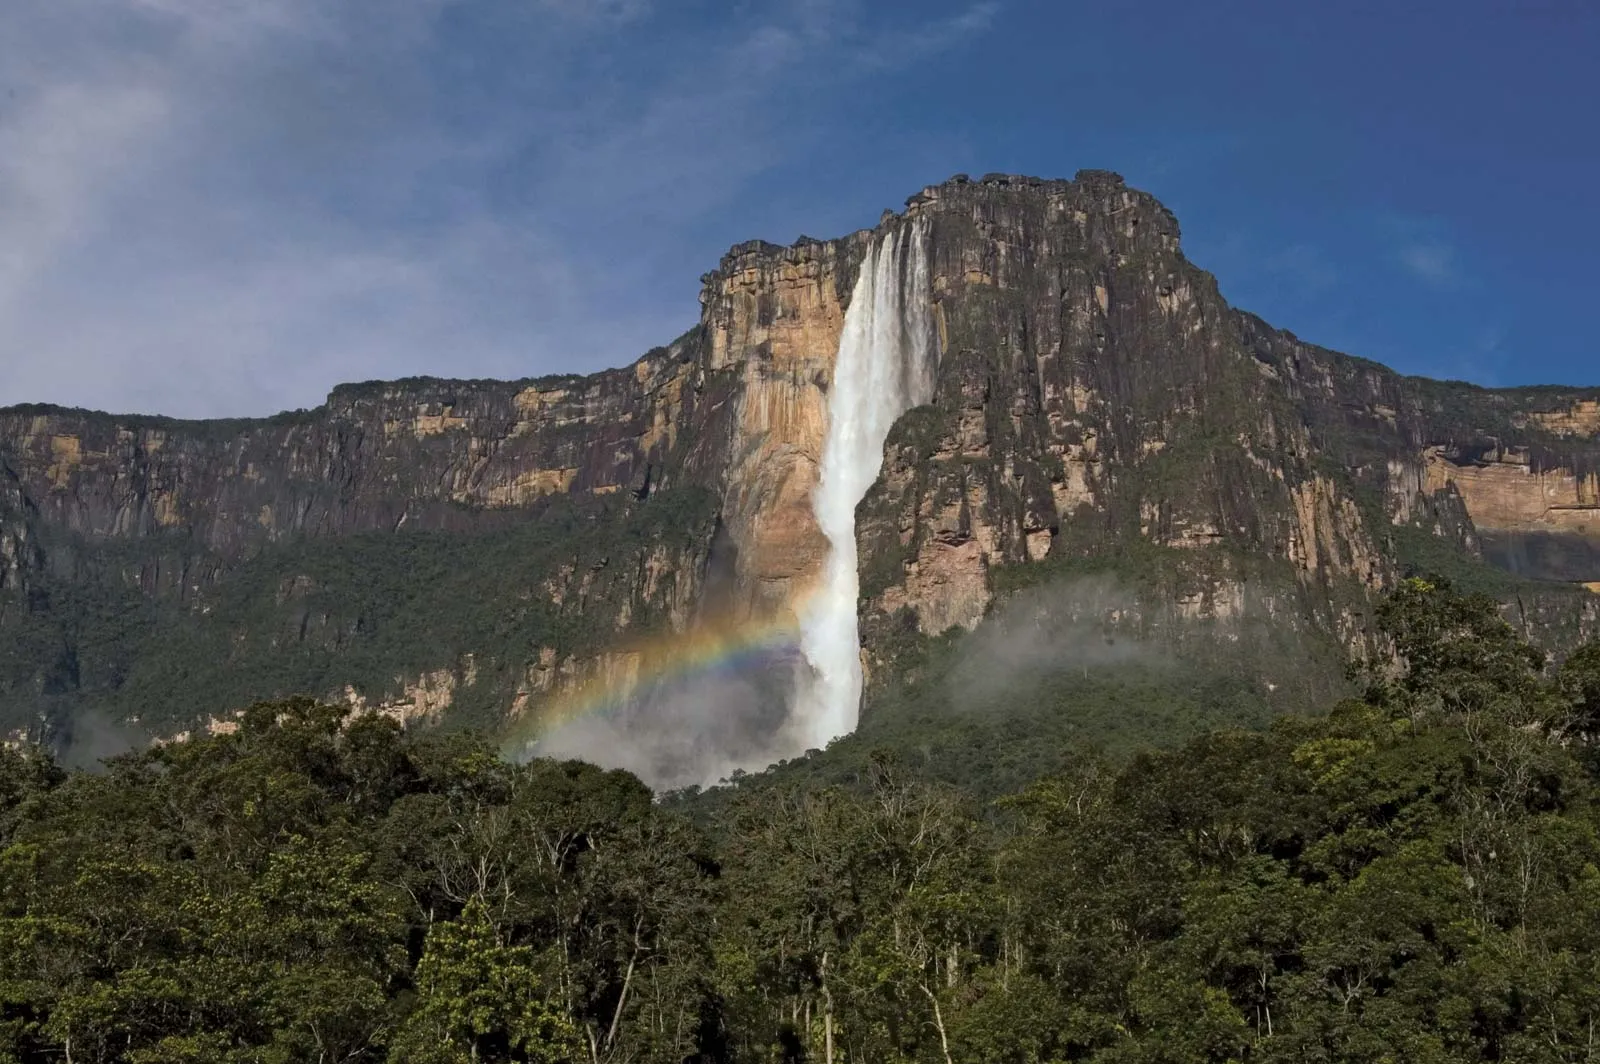What kind of experience would you get visiting this location in person? Visiting Angel Falls in person would be an unforgettable experience of natural wonder and adventure. The journey itself involves traversing dense jungles and potentially taking a boat along winding rivers, immersing you in the vibrant biodiversity of the Venezuelan rainforest. As you approach, the thunderous sound of water crashing against the rocks intensifies, and the sight of the majestic falls from the base provides a sense of awe and insignificance in comparison to nature's grandeur. The mist cooling your face and the vivid rainbow formed at the base would heighten this surreal experience, making it a destination that profoundly impacts all your senses. Can you describe the ecosystem surrounding Angel Falls? The ecosystem surrounding Angel Falls is part of the Canaima National Park, a UNESCO World Heritage Site known for its rich biodiversity and unique tepui formations. This tropical rainforest is home to numerous plant and animal species, some of which are endemic to the region. The dense vegetation includes a variety of trees, shrubs, and flora that have adapted to the humid and nutrient-rich environment. Wildlife is abundant, with sightings of howler monkeys, giant anteaters, and various bird species, including the elusive harpy eagle. The rivers and streams provide habitat for aquatic life, while the secluded areas around the falls teem with vibrant butterfly species, contributing to a dynamic and thriving ecosystem. Imagine a mythical creature residing in this area. Describe it. In this magical place, one might imagine a mythical creature known as the 'Guardian of the Falls,' a majestic entity resembling a dragon with iridescent blue and green scales that blend with the surrounding foliage. This creature has ethereal wings adorned with patterns resembling the rainforest’s flora and fauna, allowing it to camouflage seamlessly. Its eyes, bright as the rainbow at the base of the falls, are said to hold ancient wisdom and the power to control the flow of the waterfall. Legend has it that the Guardian protects the secrets of the jungle and guides lost travelers to safety, while keeping the spirit of the forest alive and flourishing. 